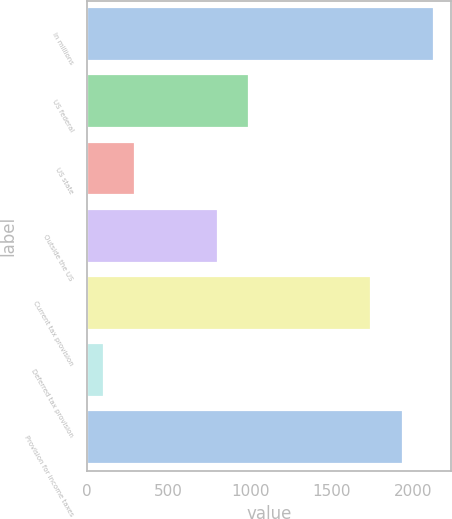Convert chart. <chart><loc_0><loc_0><loc_500><loc_500><bar_chart><fcel>In millions<fcel>US federal<fcel>US state<fcel>Outside the US<fcel>Current tax provision<fcel>Deferred tax provision<fcel>Provision for income taxes<nl><fcel>2124.6<fcel>990.85<fcel>292.15<fcel>800.2<fcel>1743.3<fcel>101.5<fcel>1933.95<nl></chart> 